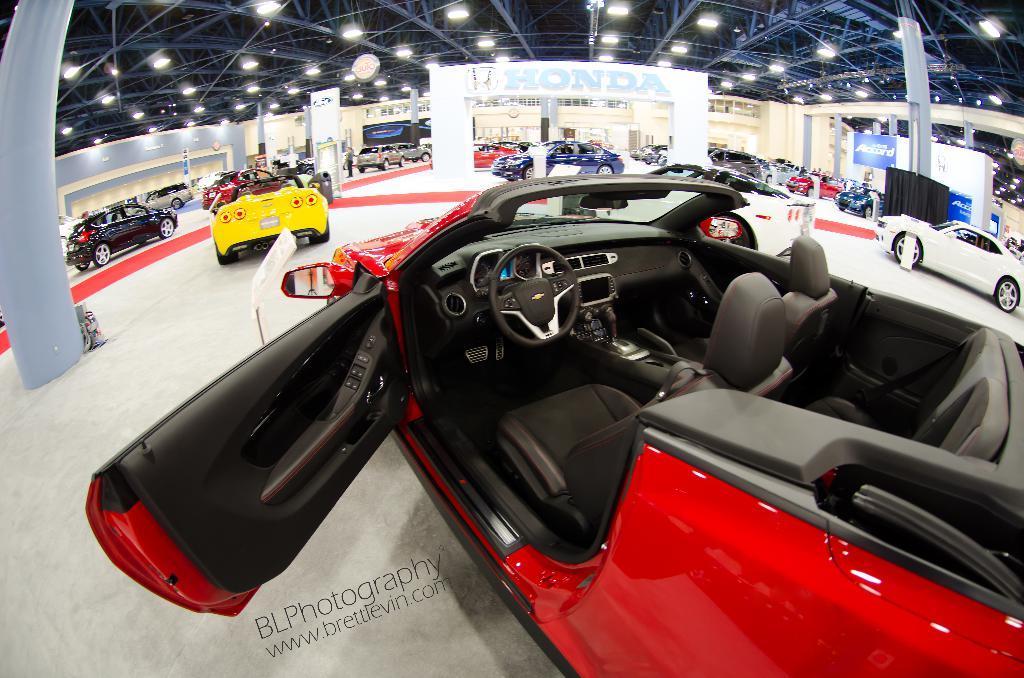Please provide a concise description of this image. In the center of the image we can see a few vehicles in different colors. At the bottom of the image, there is a watermark. In the background there is a wall, poles, lights, banners, few vehicles and a few other objects. 